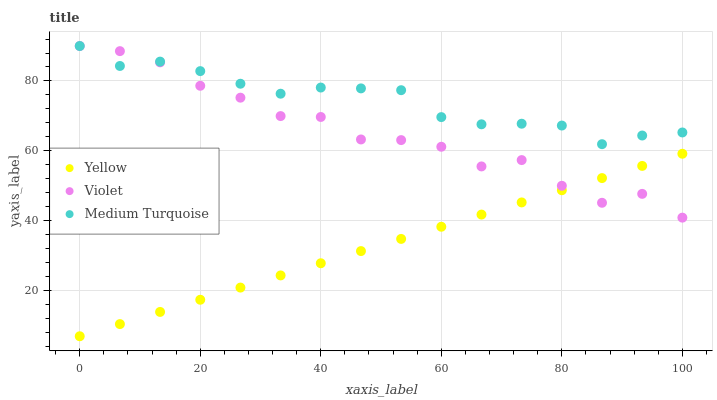Does Yellow have the minimum area under the curve?
Answer yes or no. Yes. Does Medium Turquoise have the maximum area under the curve?
Answer yes or no. Yes. Does Violet have the minimum area under the curve?
Answer yes or no. No. Does Violet have the maximum area under the curve?
Answer yes or no. No. Is Yellow the smoothest?
Answer yes or no. Yes. Is Violet the roughest?
Answer yes or no. Yes. Is Violet the smoothest?
Answer yes or no. No. Is Yellow the roughest?
Answer yes or no. No. Does Yellow have the lowest value?
Answer yes or no. Yes. Does Violet have the lowest value?
Answer yes or no. No. Does Violet have the highest value?
Answer yes or no. Yes. Does Yellow have the highest value?
Answer yes or no. No. Is Yellow less than Medium Turquoise?
Answer yes or no. Yes. Is Medium Turquoise greater than Yellow?
Answer yes or no. Yes. Does Violet intersect Medium Turquoise?
Answer yes or no. Yes. Is Violet less than Medium Turquoise?
Answer yes or no. No. Is Violet greater than Medium Turquoise?
Answer yes or no. No. Does Yellow intersect Medium Turquoise?
Answer yes or no. No. 